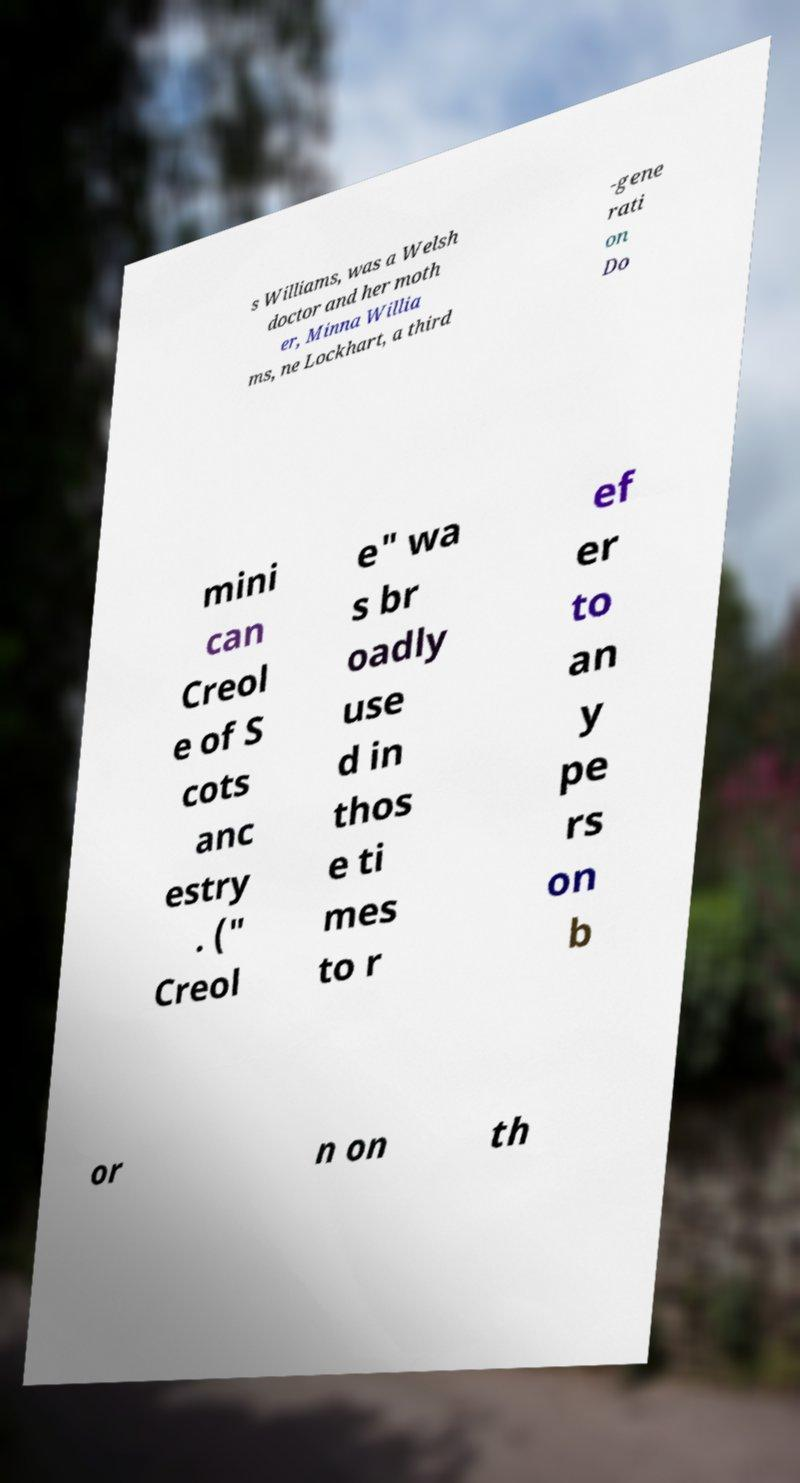Could you extract and type out the text from this image? s Williams, was a Welsh doctor and her moth er, Minna Willia ms, ne Lockhart, a third -gene rati on Do mini can Creol e of S cots anc estry . (" Creol e" wa s br oadly use d in thos e ti mes to r ef er to an y pe rs on b or n on th 